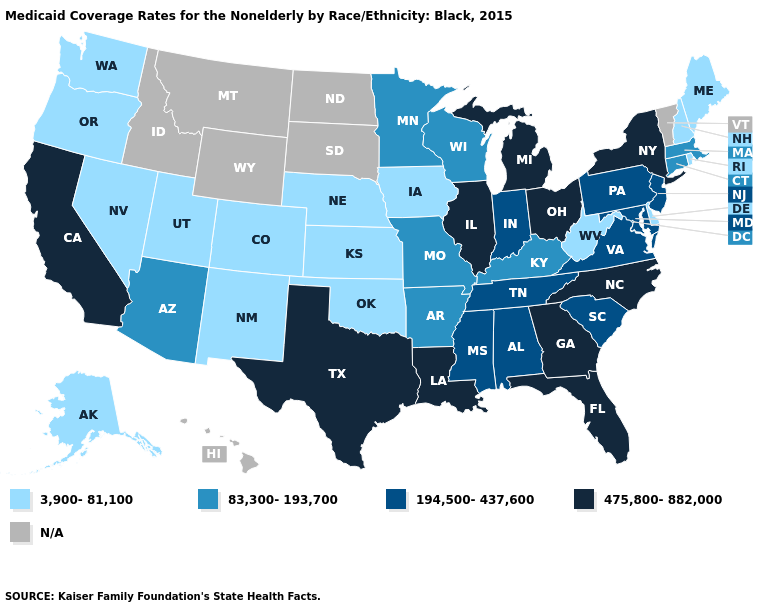What is the value of Delaware?
Write a very short answer. 3,900-81,100. What is the value of Mississippi?
Quick response, please. 194,500-437,600. Does Michigan have the highest value in the USA?
Answer briefly. Yes. Does Georgia have the lowest value in the USA?
Write a very short answer. No. What is the value of Arizona?
Quick response, please. 83,300-193,700. Name the states that have a value in the range 3,900-81,100?
Be succinct. Alaska, Colorado, Delaware, Iowa, Kansas, Maine, Nebraska, Nevada, New Hampshire, New Mexico, Oklahoma, Oregon, Rhode Island, Utah, Washington, West Virginia. What is the value of New Jersey?
Be succinct. 194,500-437,600. What is the value of Connecticut?
Give a very brief answer. 83,300-193,700. Name the states that have a value in the range N/A?
Short answer required. Hawaii, Idaho, Montana, North Dakota, South Dakota, Vermont, Wyoming. What is the lowest value in the West?
Concise answer only. 3,900-81,100. Name the states that have a value in the range 194,500-437,600?
Short answer required. Alabama, Indiana, Maryland, Mississippi, New Jersey, Pennsylvania, South Carolina, Tennessee, Virginia. What is the value of Michigan?
Write a very short answer. 475,800-882,000. Name the states that have a value in the range 3,900-81,100?
Give a very brief answer. Alaska, Colorado, Delaware, Iowa, Kansas, Maine, Nebraska, Nevada, New Hampshire, New Mexico, Oklahoma, Oregon, Rhode Island, Utah, Washington, West Virginia. 